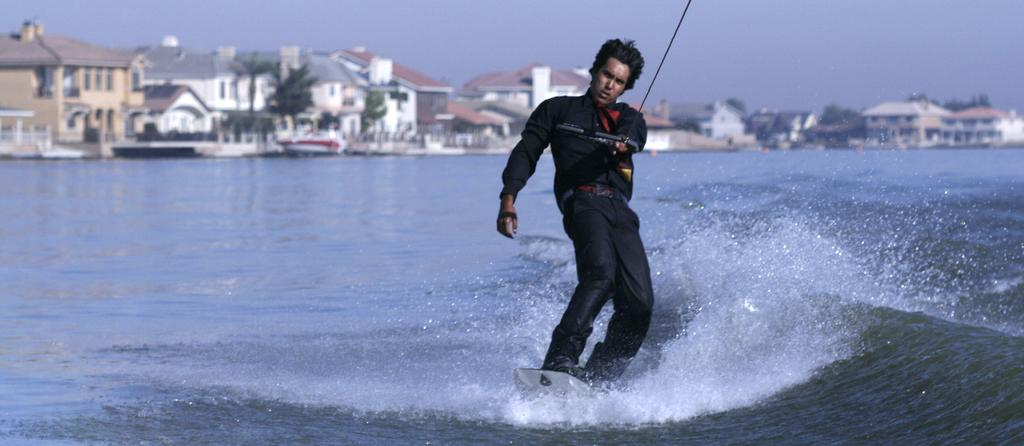Who is the person in the image? There is a man in the image. What activity is the man engaged in? The man is doing parasailing on water. What can be seen in the background of the image? There are buildings and trees in the background of the image. What is visible at the top of the image? The sky is visible at the top of the image. What type of card is the man holding while parasailing in the image? There is no card present in the image; the man is engaged in parasailing on water. 